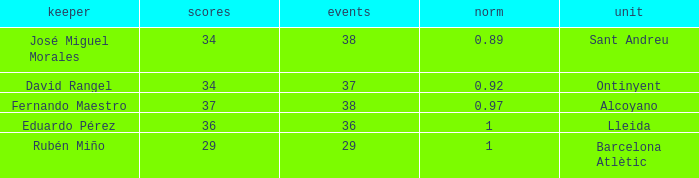What is the highest Average, when Goals is "34", and when Matches is less than 37? None. 